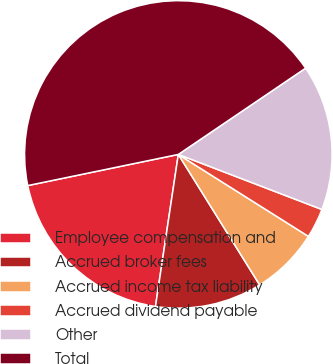<chart> <loc_0><loc_0><loc_500><loc_500><pie_chart><fcel>Employee compensation and<fcel>Accrued broker fees<fcel>Accrued income tax liability<fcel>Accrued dividend payable<fcel>Other<fcel>Total<nl><fcel>19.38%<fcel>11.25%<fcel>7.18%<fcel>3.12%<fcel>15.31%<fcel>43.77%<nl></chart> 